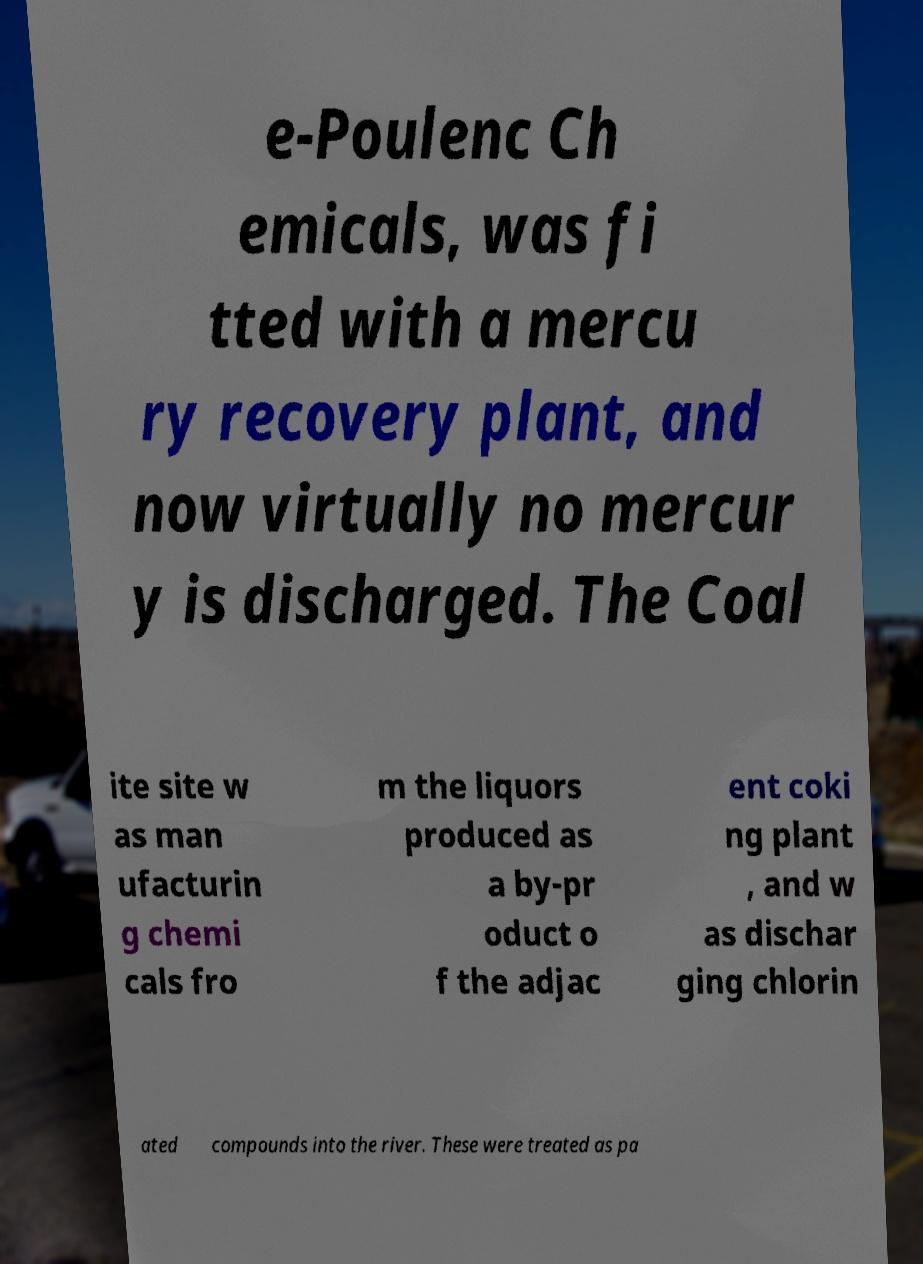Can you accurately transcribe the text from the provided image for me? e-Poulenc Ch emicals, was fi tted with a mercu ry recovery plant, and now virtually no mercur y is discharged. The Coal ite site w as man ufacturin g chemi cals fro m the liquors produced as a by-pr oduct o f the adjac ent coki ng plant , and w as dischar ging chlorin ated compounds into the river. These were treated as pa 